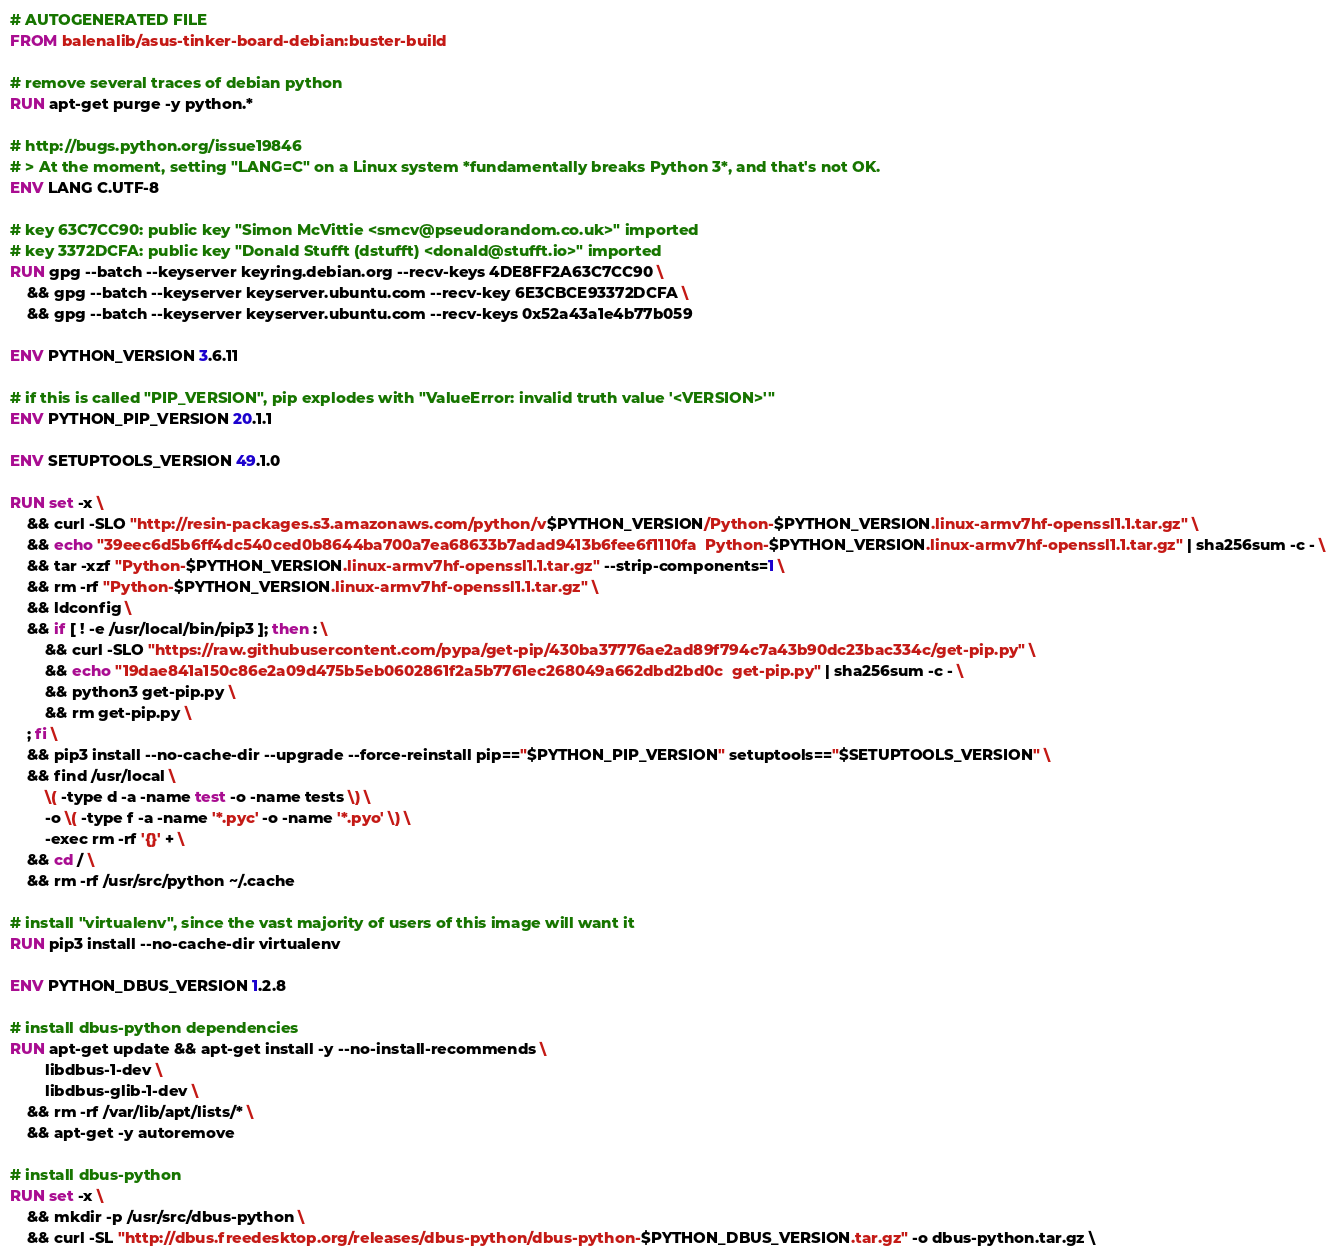<code> <loc_0><loc_0><loc_500><loc_500><_Dockerfile_># AUTOGENERATED FILE
FROM balenalib/asus-tinker-board-debian:buster-build

# remove several traces of debian python
RUN apt-get purge -y python.*

# http://bugs.python.org/issue19846
# > At the moment, setting "LANG=C" on a Linux system *fundamentally breaks Python 3*, and that's not OK.
ENV LANG C.UTF-8

# key 63C7CC90: public key "Simon McVittie <smcv@pseudorandom.co.uk>" imported
# key 3372DCFA: public key "Donald Stufft (dstufft) <donald@stufft.io>" imported
RUN gpg --batch --keyserver keyring.debian.org --recv-keys 4DE8FF2A63C7CC90 \
	&& gpg --batch --keyserver keyserver.ubuntu.com --recv-key 6E3CBCE93372DCFA \
	&& gpg --batch --keyserver keyserver.ubuntu.com --recv-keys 0x52a43a1e4b77b059

ENV PYTHON_VERSION 3.6.11

# if this is called "PIP_VERSION", pip explodes with "ValueError: invalid truth value '<VERSION>'"
ENV PYTHON_PIP_VERSION 20.1.1

ENV SETUPTOOLS_VERSION 49.1.0

RUN set -x \
	&& curl -SLO "http://resin-packages.s3.amazonaws.com/python/v$PYTHON_VERSION/Python-$PYTHON_VERSION.linux-armv7hf-openssl1.1.tar.gz" \
	&& echo "39eec6d5b6ff4dc540ced0b8644ba700a7ea68633b7adad9413b6fee6f1110fa  Python-$PYTHON_VERSION.linux-armv7hf-openssl1.1.tar.gz" | sha256sum -c - \
	&& tar -xzf "Python-$PYTHON_VERSION.linux-armv7hf-openssl1.1.tar.gz" --strip-components=1 \
	&& rm -rf "Python-$PYTHON_VERSION.linux-armv7hf-openssl1.1.tar.gz" \
	&& ldconfig \
	&& if [ ! -e /usr/local/bin/pip3 ]; then : \
		&& curl -SLO "https://raw.githubusercontent.com/pypa/get-pip/430ba37776ae2ad89f794c7a43b90dc23bac334c/get-pip.py" \
		&& echo "19dae841a150c86e2a09d475b5eb0602861f2a5b7761ec268049a662dbd2bd0c  get-pip.py" | sha256sum -c - \
		&& python3 get-pip.py \
		&& rm get-pip.py \
	; fi \
	&& pip3 install --no-cache-dir --upgrade --force-reinstall pip=="$PYTHON_PIP_VERSION" setuptools=="$SETUPTOOLS_VERSION" \
	&& find /usr/local \
		\( -type d -a -name test -o -name tests \) \
		-o \( -type f -a -name '*.pyc' -o -name '*.pyo' \) \
		-exec rm -rf '{}' + \
	&& cd / \
	&& rm -rf /usr/src/python ~/.cache

# install "virtualenv", since the vast majority of users of this image will want it
RUN pip3 install --no-cache-dir virtualenv

ENV PYTHON_DBUS_VERSION 1.2.8

# install dbus-python dependencies 
RUN apt-get update && apt-get install -y --no-install-recommends \
		libdbus-1-dev \
		libdbus-glib-1-dev \
	&& rm -rf /var/lib/apt/lists/* \
	&& apt-get -y autoremove

# install dbus-python
RUN set -x \
	&& mkdir -p /usr/src/dbus-python \
	&& curl -SL "http://dbus.freedesktop.org/releases/dbus-python/dbus-python-$PYTHON_DBUS_VERSION.tar.gz" -o dbus-python.tar.gz \</code> 